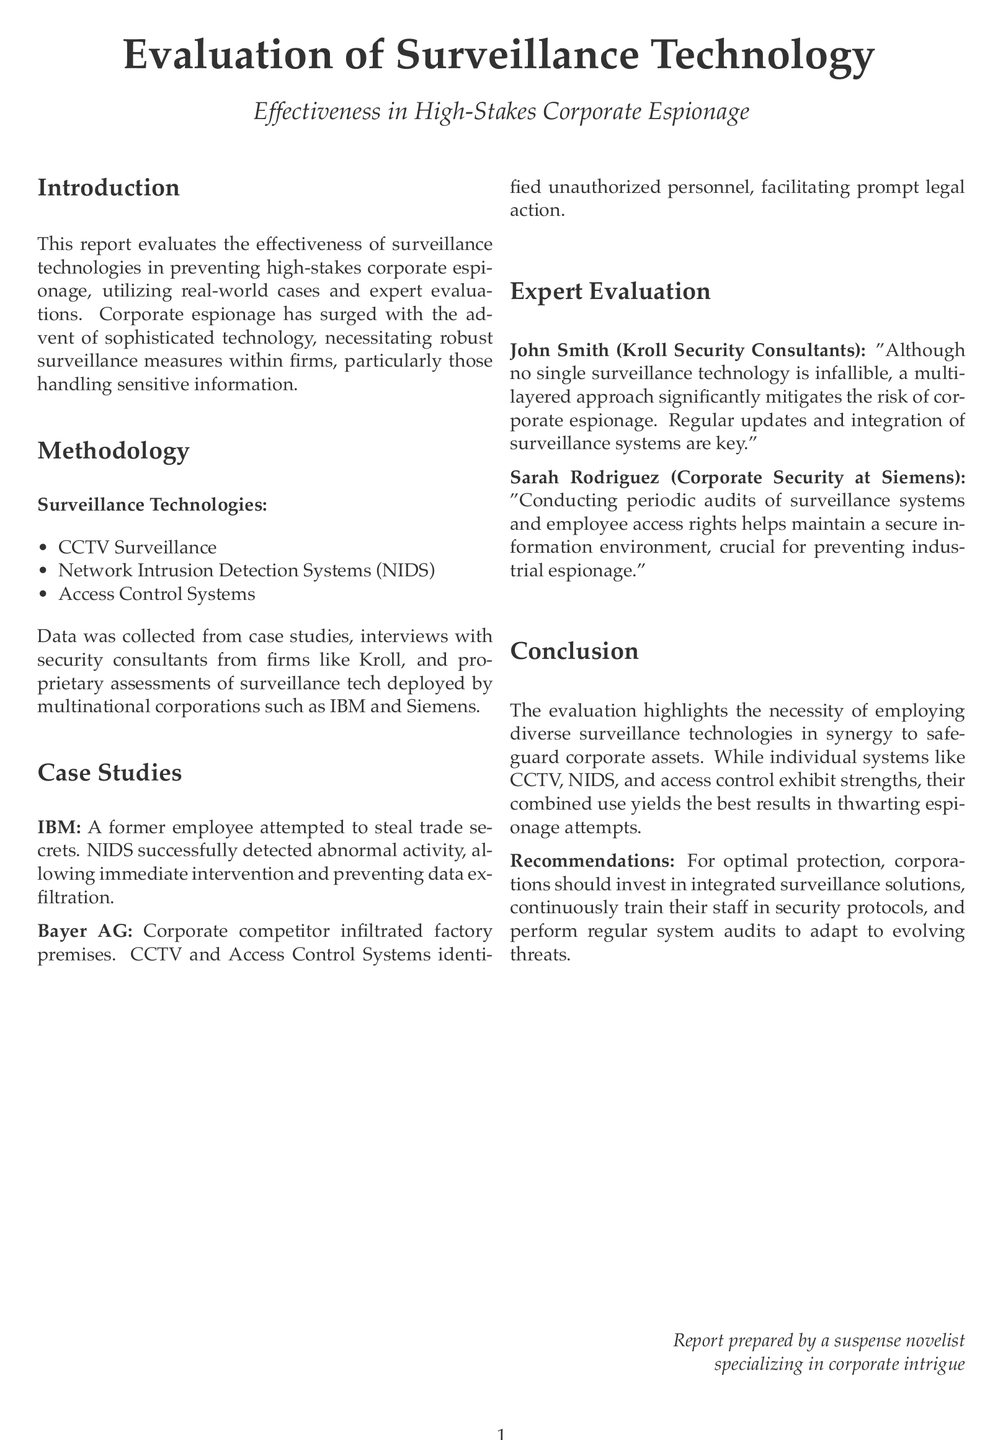What is the title of the report? The title is mentioned in the center of the document, indicating the focus of the report.
Answer: Evaluation of Surveillance Technology Effectiveness in High-Stakes Corporate Espionage What methodology is used in the report? The methodology list includes specific surveillance technologies evaluated in the report.
Answer: Surveillance Technologies How many case studies are presented in the report? The document explicitly lists two case studies involving different companies.
Answer: Two Who is the expert from Kroll Security Consultants? The report mentions a specific expert providing insight on surveillance technology.
Answer: John Smith What type of systems does Sarah Rodriguez emphasize for maintaining security? The report notes her focus on reviewing systems and access rights to enhance security measures.
Answer: Periodic audits What is the primary effect of Network Intrusion Detection Systems mentioned in the IBM case study? The case study provides a direct outcome related to a specific incident involving IBM.
Answer: Detected abnormal activity What is the main recommendation given for corporations? The recommendations section summarizes the critical actions corporations should consider post-evaluation.
Answer: Invest in integrated surveillance solutions What does the report conclude about using different surveillance technologies? The conclusion emphasizes the importance of a particular approach to utilizing surveillance systems together.
Answer: Necessary to employ diverse technologies in synergy What was the incident at Bayer AG? The document provides a specific event that showcases the effectiveness of the surveillance systems in question.
Answer: Corporate competitor infiltrated factory premises 